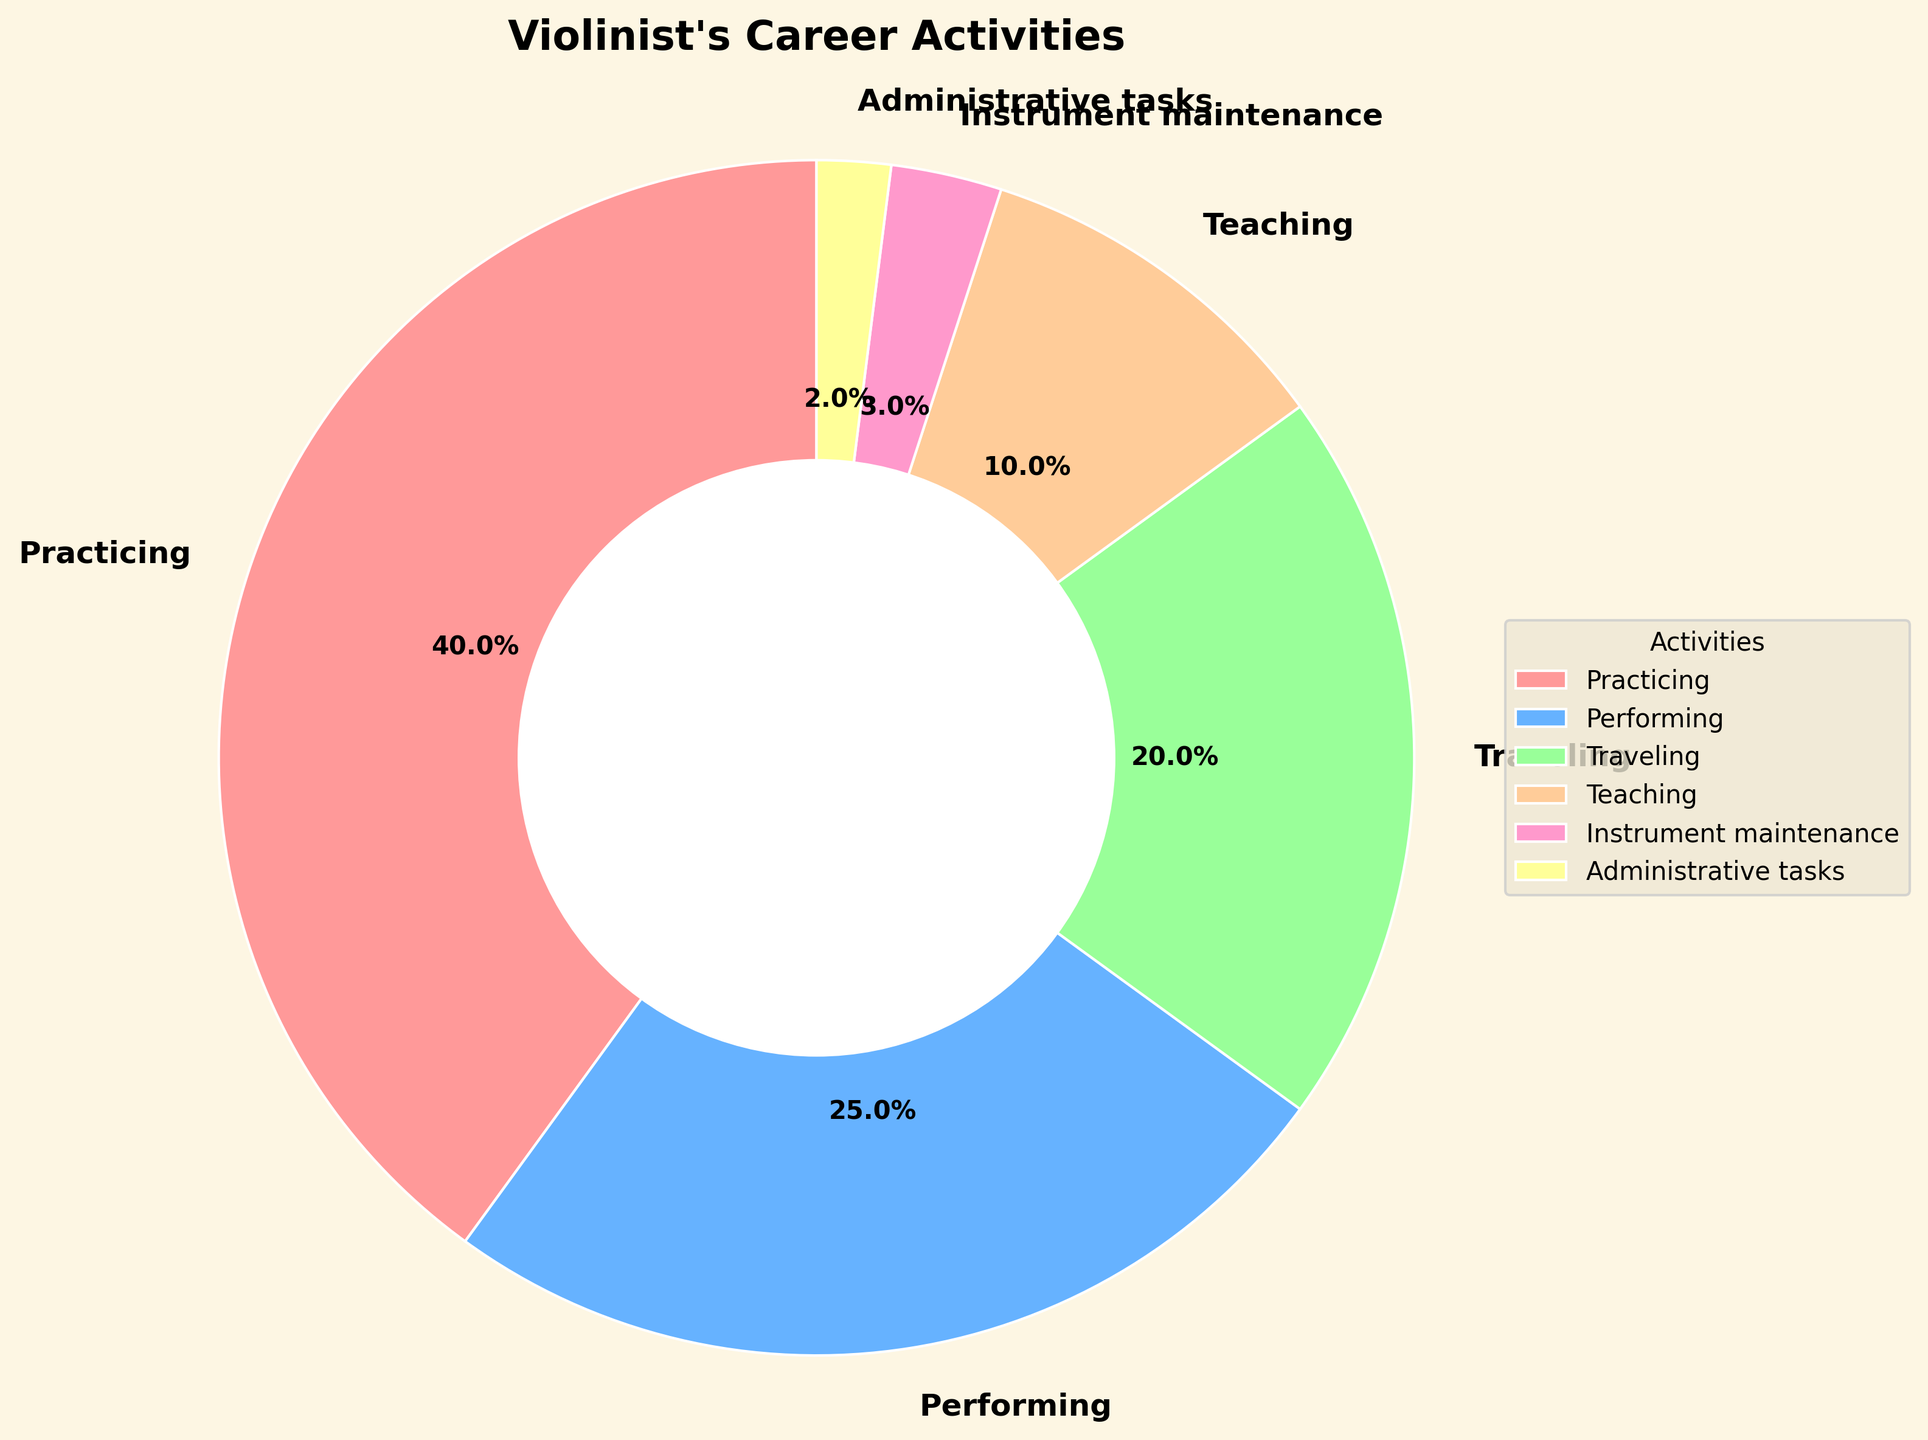Which activity takes up the largest proportion of time in a violinist's career? The figure shows the activities and their respective proportions. Practicing occupies the largest segment.
Answer: Practicing What is the total proportion of time dedicated to performing and teaching? Add the percentages of performing and teaching: 25% (performing) + 10% (teaching) = 35%.
Answer: 35% Between traveling and teaching, which one takes up more time, and by how much? Traveling is 20% and teaching is 10%. The difference is 20% - 10% = 10%.
Answer: Traveling by 10% In terms of proportion, how much time is spent on administrative tasks compared to instrument maintenance? Administrative tasks are 2% and instrument maintenance is 3%. Comparing these, 2% is less than 3%.
Answer: Less time on administrative tasks What is the combined proportion of time spent on activities other than practicing and performing? Sum the proportions of traveling, teaching, instrument maintenance, and administrative tasks: 20% + 10% + 3% + 2% = 35%.
Answer: 35% Which activity is represented by the smallest segment in the pie chart? The figure shows that administrative tasks have the smallest segment, at 2%.
Answer: Administrative tasks If a violinist spends an hour on each activity in proportion to the pie chart, how much time will they spend practicing? Practicing accounts for 40% of time. 40% of 1 hour = 0.4 hours or 24 minutes.
Answer: 24 minutes How does the proportion of time spent on practicing compare to the combined proportion of performing and traveling? Practicing is 40%, while performing and traveling combined is 25% + 20% = 45%. Practicing is 5% less.
Answer: 5% less What is the proportion difference between teaching and instrument maintenance? Teaching is 10% and instrument maintenance is 3%. The difference is 10% - 3% = 7%.
Answer: 7% 